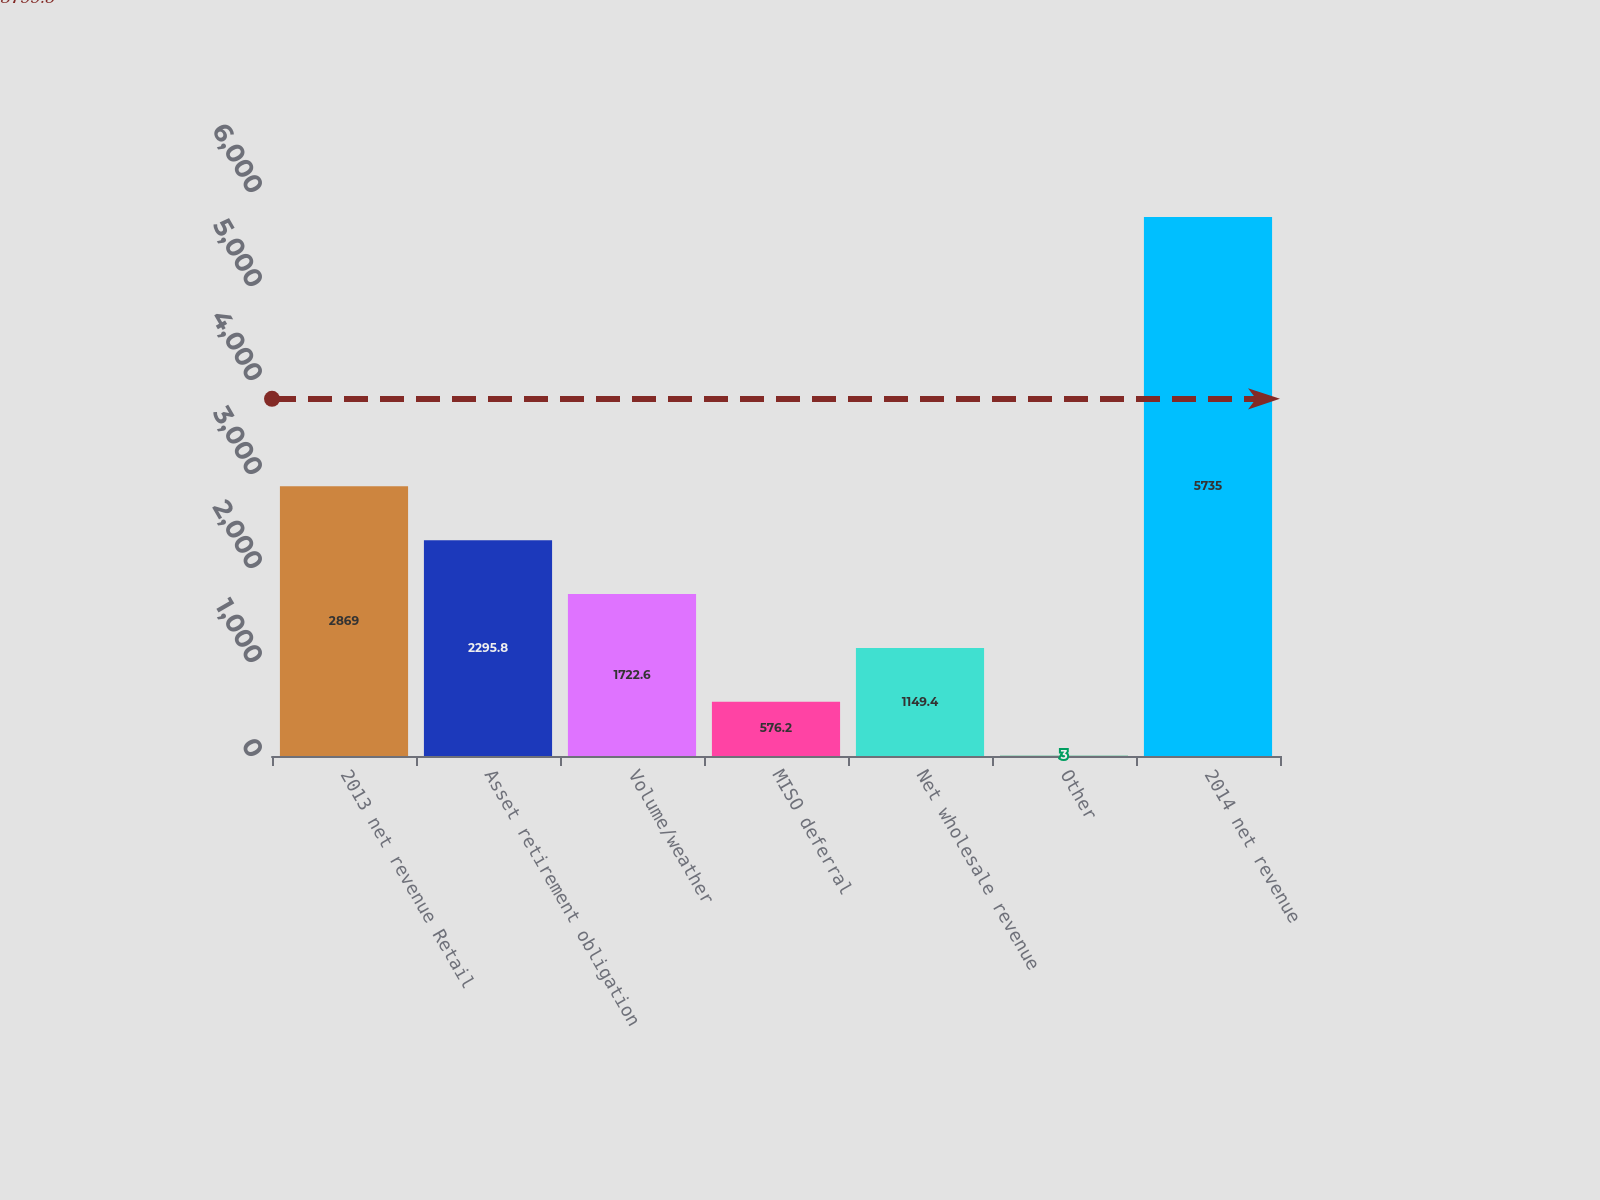Convert chart. <chart><loc_0><loc_0><loc_500><loc_500><bar_chart><fcel>2013 net revenue Retail<fcel>Asset retirement obligation<fcel>Volume/weather<fcel>MISO deferral<fcel>Net wholesale revenue<fcel>Other<fcel>2014 net revenue<nl><fcel>2869<fcel>2295.8<fcel>1722.6<fcel>576.2<fcel>1149.4<fcel>3<fcel>5735<nl></chart> 